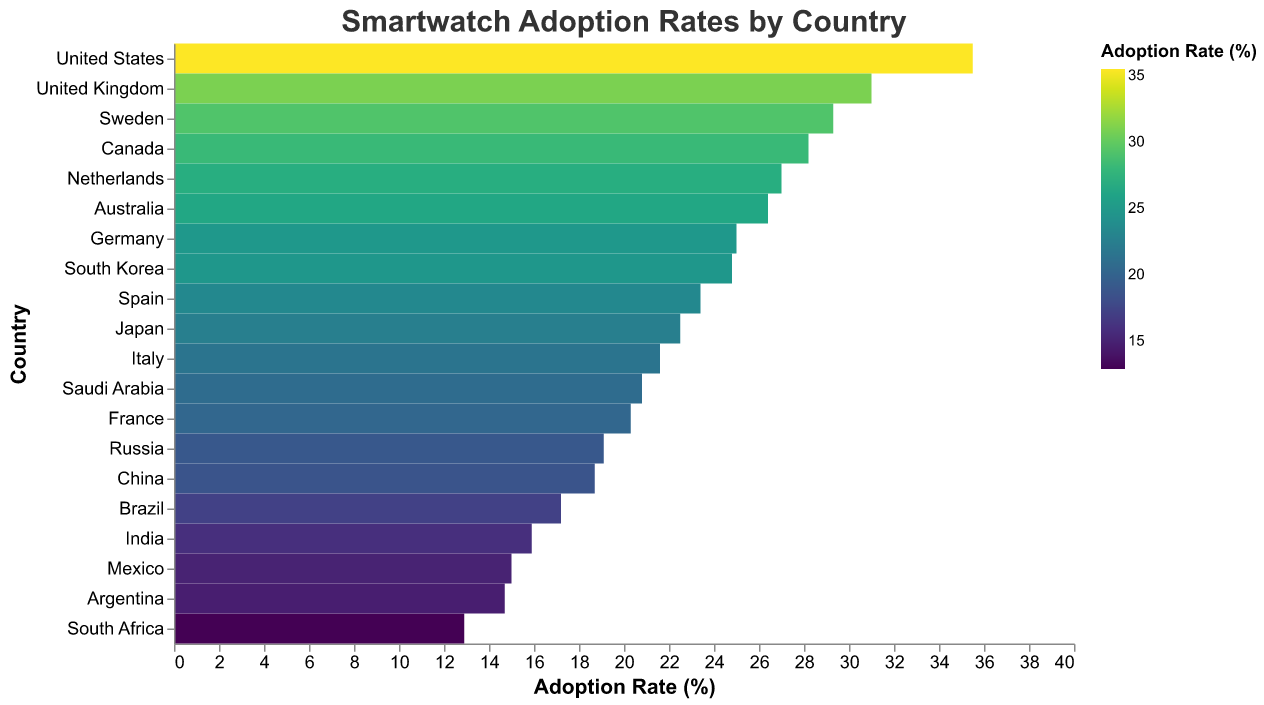which country has the highest smartwatch adoption rate? Observe the colors and numerical values for each country in the heatmap. The United States has the darkest color and the highest adoption rate of 35.5%.
Answer: United States which country has a smartwatch adoption rate closest to 20%? Compare the adoption rates listed against 20%. France, with a rate of 20.3%, is the closest.
Answer: France how many countries have a smartwatch adoption rate above 25%? Identify all countries with rates above 25% from the heatmap. They are: United States, Canada, United Kingdom, Netherlands, Sweden, and Australia. Count them.
Answer: 6 which has a higher smartwatch adoption rate: Japan or Spain? Look for the adoption rates of Japan and Spain in the heatmap. Japan has 22.5% while Spain has 23.4%.
Answer: Spain what is the average smartwatch adoption rate among South Korea, China, and India? Add the adoption rates of South Korea (24.8%), China (18.7%), and India (15.9%), then divide by 3: (24.8 + 18.7 + 15.9) / 3 = 19.8%.
Answer: 19.8 how does the adoption rate in Sweden compare to that in Canada? Sweden has an adoption rate of 29.3%, and Canada has 28.2%. Sweden's rate is slightly higher.
Answer: Sweden has a higher adoption rate what is the adoption rate difference between the United States and Mexico? Subtract Mexico's adoption rate (15.0%) from the United States (35.5%): 35.5 - 15.0 = 20.5%.
Answer: 20.5 which country has the lowest adoption rate of smartwatches? Identify the country with the lightest color and lowest numerical value. South Africa, with 12.9%, has the lowest adoption rate.
Answer: South Africa rank the adoption rates of Italy, Netherlands, and Canada from highest to lowest. Identify and rank their adoption rates: Netherlands (27.0%), Canada (28.2%), and Italy (21.6%). The order from highest to lowest is: Canada, Netherlands, Italy.
Answer: Canada, Netherlands, Italy 